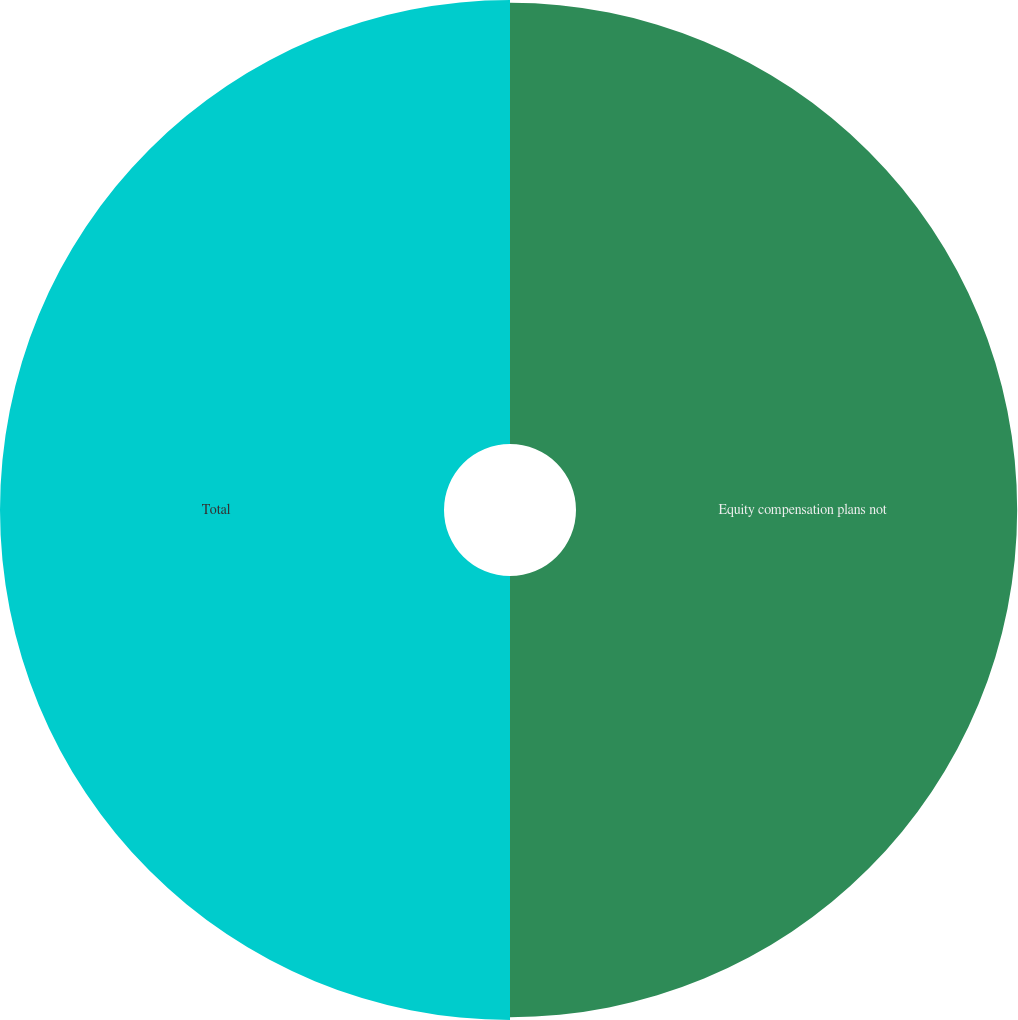Convert chart. <chart><loc_0><loc_0><loc_500><loc_500><pie_chart><fcel>Equity compensation plans not<fcel>Total<nl><fcel>49.84%<fcel>50.16%<nl></chart> 